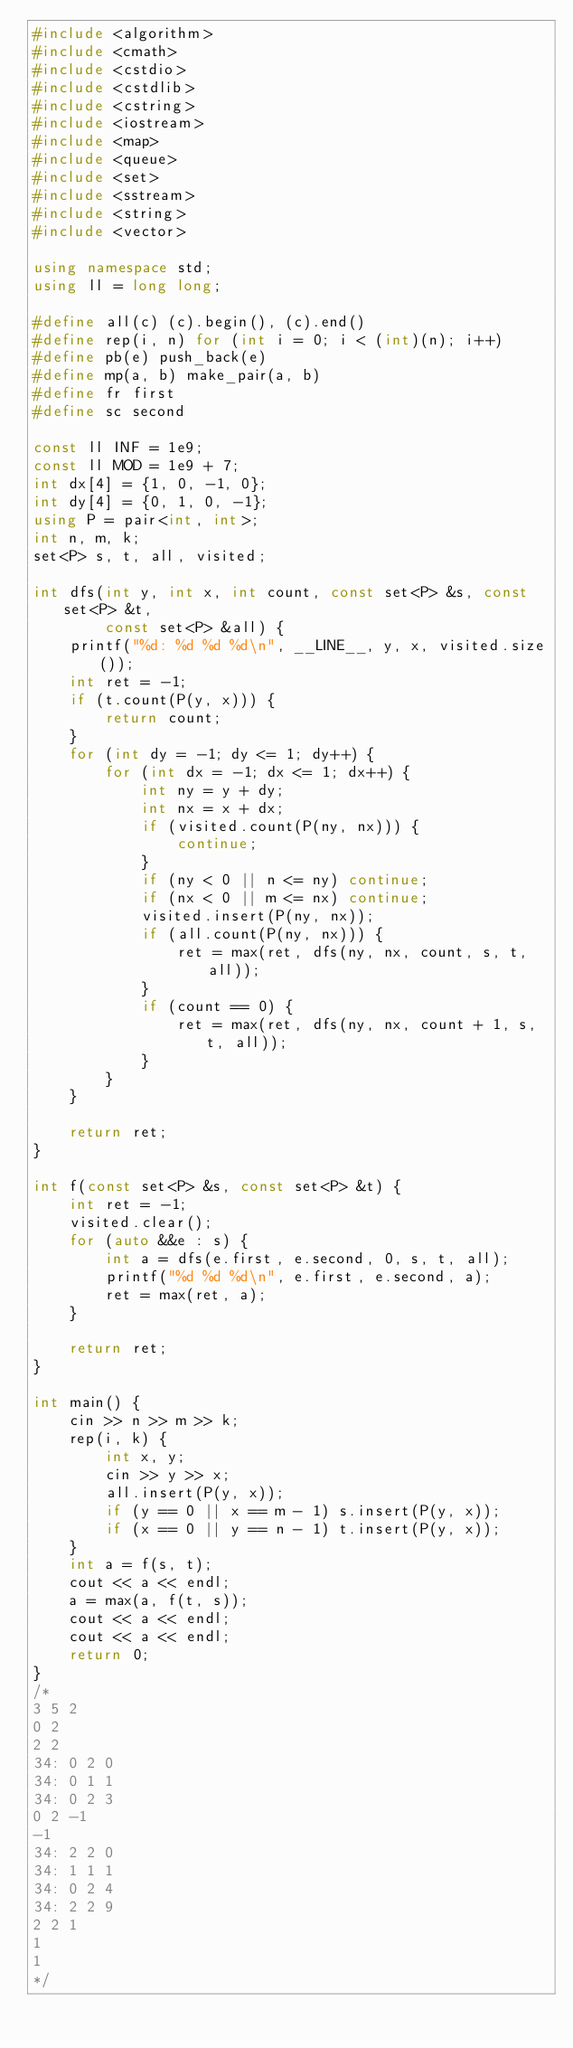<code> <loc_0><loc_0><loc_500><loc_500><_C++_>#include <algorithm>
#include <cmath>
#include <cstdio>
#include <cstdlib>
#include <cstring>
#include <iostream>
#include <map>
#include <queue>
#include <set>
#include <sstream>
#include <string>
#include <vector>

using namespace std;
using ll = long long;

#define all(c) (c).begin(), (c).end()
#define rep(i, n) for (int i = 0; i < (int)(n); i++)
#define pb(e) push_back(e)
#define mp(a, b) make_pair(a, b)
#define fr first
#define sc second

const ll INF = 1e9;
const ll MOD = 1e9 + 7;
int dx[4] = {1, 0, -1, 0};
int dy[4] = {0, 1, 0, -1};
using P = pair<int, int>;
int n, m, k;
set<P> s, t, all, visited;

int dfs(int y, int x, int count, const set<P> &s, const set<P> &t,
        const set<P> &all) {
    printf("%d: %d %d %d\n", __LINE__, y, x, visited.size());
    int ret = -1;
    if (t.count(P(y, x))) {
        return count;
    }
    for (int dy = -1; dy <= 1; dy++) {
        for (int dx = -1; dx <= 1; dx++) {
            int ny = y + dy;
            int nx = x + dx;
            if (visited.count(P(ny, nx))) {
                continue;
            }
            if (ny < 0 || n <= ny) continue;
            if (nx < 0 || m <= nx) continue;
            visited.insert(P(ny, nx));
            if (all.count(P(ny, nx))) {
                ret = max(ret, dfs(ny, nx, count, s, t, all));
            }
            if (count == 0) {
                ret = max(ret, dfs(ny, nx, count + 1, s, t, all));
            }
        }
    }

    return ret;
}

int f(const set<P> &s, const set<P> &t) {
    int ret = -1;
    visited.clear();
    for (auto &&e : s) {
        int a = dfs(e.first, e.second, 0, s, t, all);
        printf("%d %d %d\n", e.first, e.second, a);
        ret = max(ret, a);
    }

    return ret;
}

int main() {
    cin >> n >> m >> k;
    rep(i, k) {
        int x, y;
        cin >> y >> x;
        all.insert(P(y, x));
        if (y == 0 || x == m - 1) s.insert(P(y, x));
        if (x == 0 || y == n - 1) t.insert(P(y, x));
    }
    int a = f(s, t);
    cout << a << endl;
    a = max(a, f(t, s));
    cout << a << endl;
    cout << a << endl;
    return 0;
}
/*
3 5 2
0 2
2 2
34: 0 2 0
34: 0 1 1
34: 0 2 3
0 2 -1
-1
34: 2 2 0
34: 1 1 1
34: 0 2 4
34: 2 2 9
2 2 1
1
1
*/</code> 